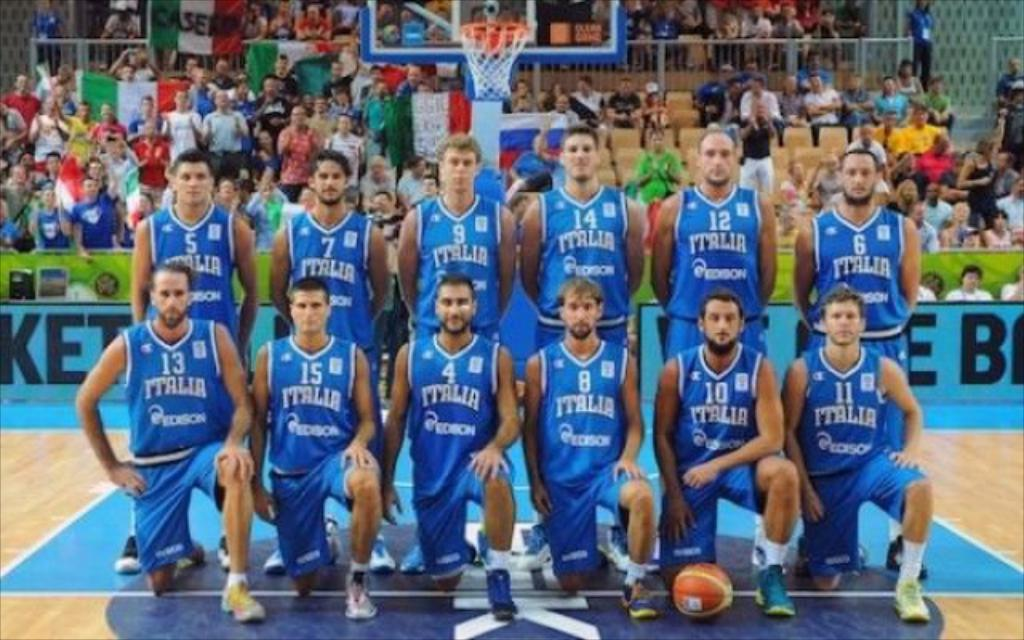<image>
Offer a succinct explanation of the picture presented. Basketball Team with Italia on the front of their uniforms posing for a picture. 